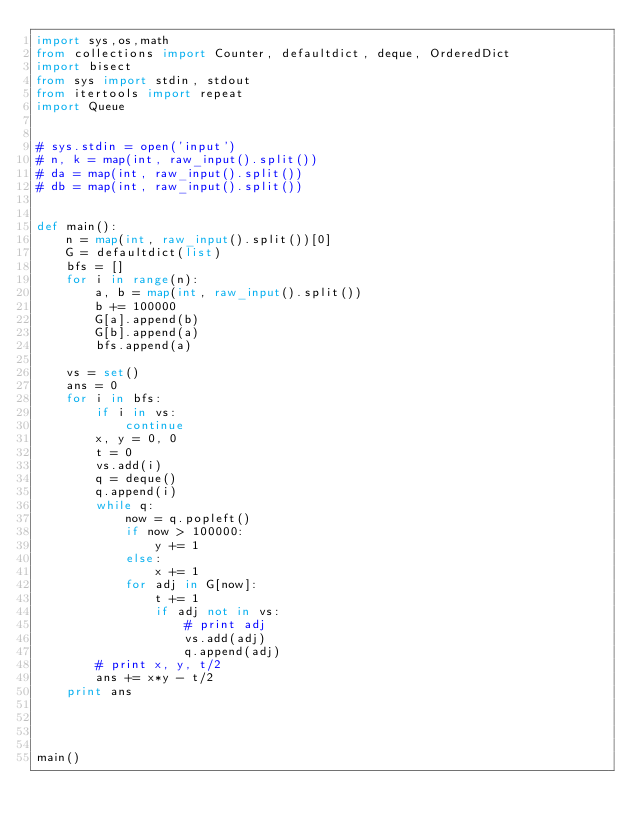<code> <loc_0><loc_0><loc_500><loc_500><_Python_>import sys,os,math
from collections import Counter, defaultdict, deque, OrderedDict
import bisect
from sys import stdin, stdout
from itertools import repeat
import Queue


# sys.stdin = open('input')
# n, k = map(int, raw_input().split())
# da = map(int, raw_input().split())
# db = map(int, raw_input().split())


def main():
    n = map(int, raw_input().split())[0]
    G = defaultdict(list)
    bfs = []
    for i in range(n):
        a, b = map(int, raw_input().split())
        b += 100000
        G[a].append(b)
        G[b].append(a)
        bfs.append(a)

    vs = set()
    ans = 0
    for i in bfs:
        if i in vs:
            continue
        x, y = 0, 0
        t = 0
        vs.add(i)
        q = deque()
        q.append(i)
        while q:
            now = q.popleft()
            if now > 100000:
                y += 1
            else:
                x += 1
            for adj in G[now]:
                t += 1
                if adj not in vs:
                    # print adj
                    vs.add(adj)
                    q.append(adj)
        # print x, y, t/2
        ans += x*y - t/2
    print ans




main()
</code> 